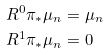<formula> <loc_0><loc_0><loc_500><loc_500>R ^ { 0 } \pi _ { \ast } \mu _ { n } & = \mu _ { n } \\ R ^ { 1 } \pi _ { \ast } \mu _ { n } & = 0</formula> 